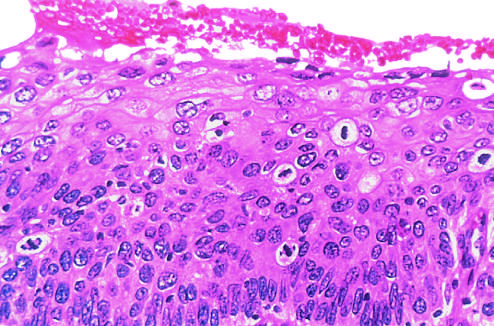does the high-power view show failure of normal differentiation, marked nuclear and cellular pleomorphism, and numerous mitotic figures extending toward the surface?
Answer the question using a single word or phrase. Yes 